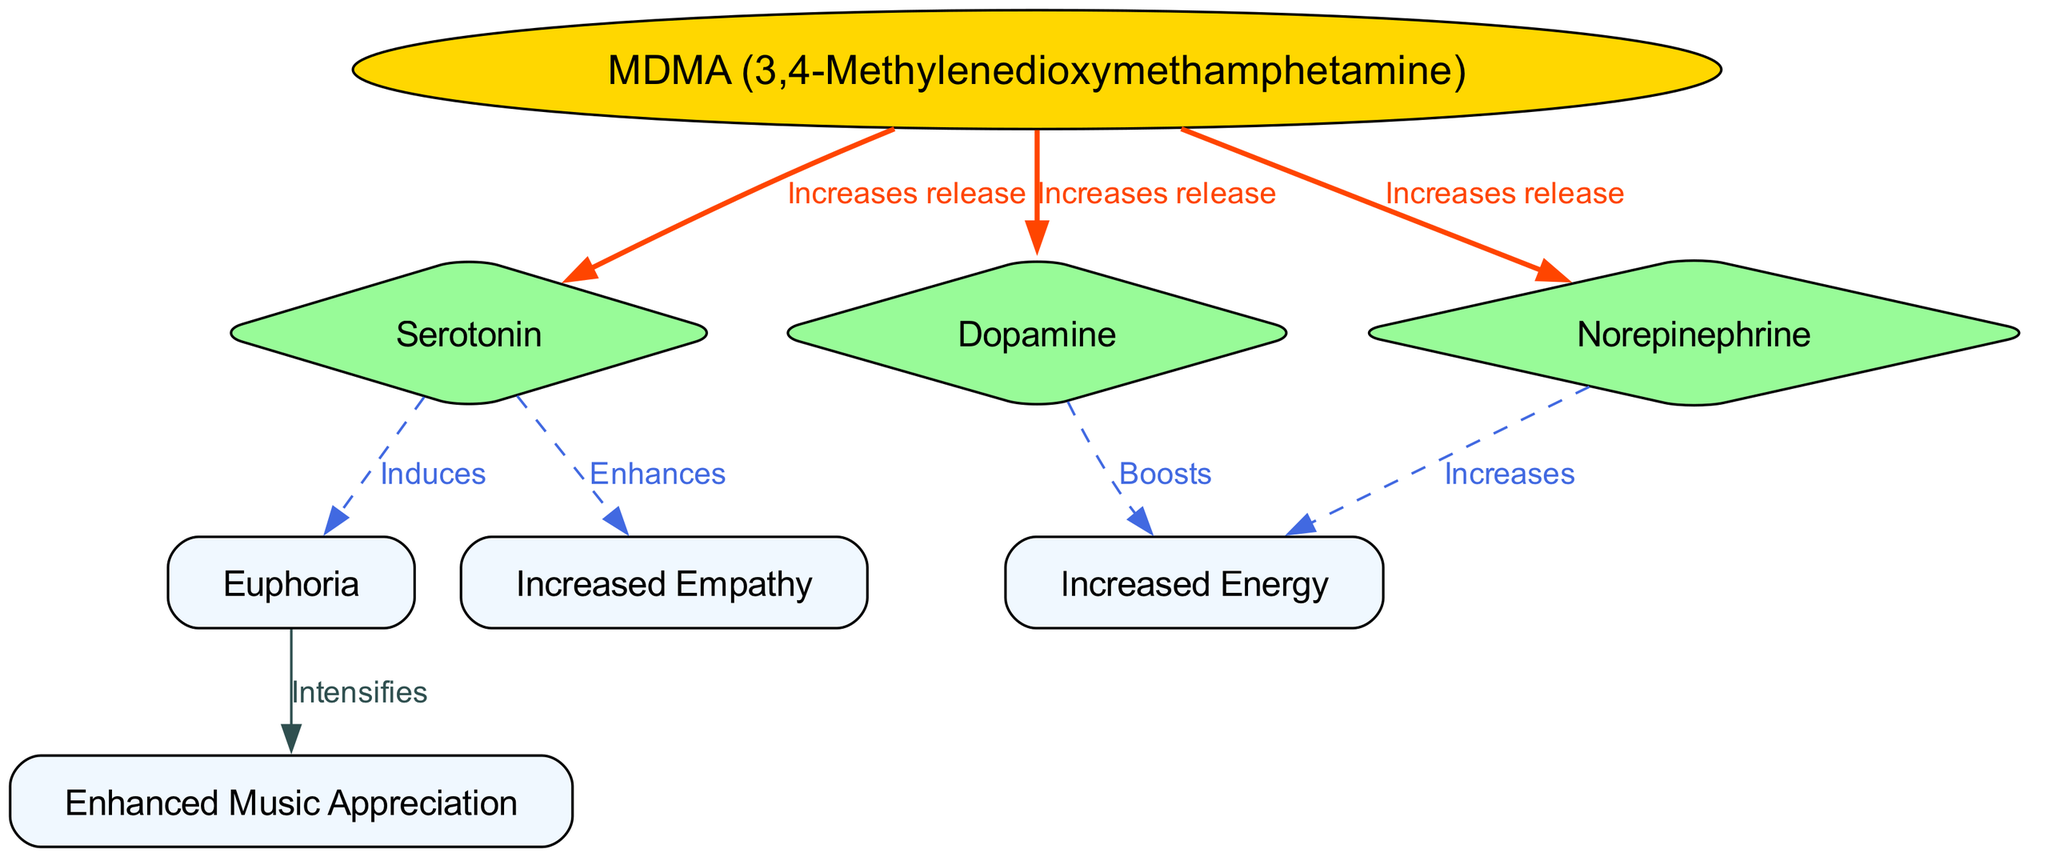What is the label of the node representing MDMA? The node for MDMA specifically states "MDMA (3,4-Methylenedioxymethamphetamine)" as its label. This information is directly visible in the diagram at the designated node for MDMA.
Answer: MDMA (3,4-Methylenedioxymethamphetamine) How many nodes are present in the diagram? By counting each unique box represented, including MDMA and effects, we can determine there are 8 nodes in total: MDMA, Serotonin, Dopamine, Norepinephrine, Euphoria, Increased Empathy, Increased Energy, and Enhanced Music Appreciation.
Answer: 8 What effect does serotonin induce? The diagram indicates that serotonin specifically induces "Euphoria", directly connecting the "Serotonin" node to the "Euphoria" node with an edge labeled "Induces".
Answer: Euphoria Which chemical is associated with increased energy boosts? The diagram shows that both "Dopamine" and "Norepinephrine" are linked to "Increased Energy", where they increase and boost energy levels respectively, indicated by their connecting edges.
Answer: Dopamine and Norepinephrine What relationship exists between MDMA and norepinephrine? MDMA is indicated to "Increase release" of norepinephrine, demonstrating a direct effect of MDMA on this chemical, shown by the edge connecting these two nodes and labeled accordingly.
Answer: Increases release Which effect intensifies the appreciation of music? The diagram explicitly states that the effect "Euphoria" intensifies "Enhanced Music Appreciation," indicating a strong cognitive relationship between the experience induced by MDMA and music perception.
Answer: Intensifies What is the common effect of both dopamine and norepinephrine in the diagram? Both chemicals lead to "Increased Energy" as noted in the diagram connections where they contribute to energy levels independently, demonstrated by the edges leading to the "Increased Energy" node.
Answer: Increased Energy How does serotonin enhance empathy? The relationship noted in the diagram shows that serotonin not only has a connection to "Euphoria" but specifically enhances "Increased Empathy", thereby depicting its role in emotional processing.
Answer: Enhances In how many ways does MDMA affect the human brain in this diagram? MDMA interacts with three distinct neurochemicals: serotonin, dopamine, and norepinephrine, which then create various resulting effects. There are three connections that indicate its influence through these neurotransmitters.
Answer: Three ways 